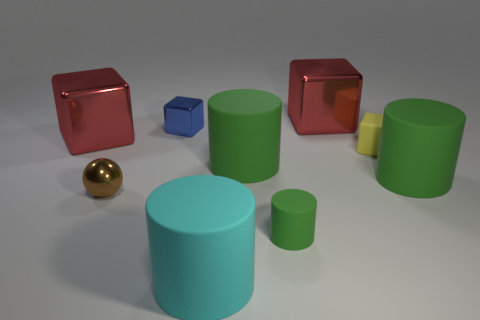Is the material of the large red thing that is on the left side of the blue metallic cube the same as the small cube that is to the right of the blue metal cube?
Your response must be concise. No. Does the small brown sphere have the same material as the small yellow block?
Provide a short and direct response. No. What number of big things are the same material as the small yellow cube?
Your answer should be compact. 3. There is a big matte thing on the right side of the yellow matte object; is its color the same as the tiny matte cylinder?
Give a very brief answer. Yes. How many other small objects have the same shape as the cyan matte thing?
Give a very brief answer. 1. Are there the same number of green matte cylinders left of the small green matte object and small metal balls?
Provide a short and direct response. Yes. The other matte block that is the same size as the blue cube is what color?
Give a very brief answer. Yellow. Is there a large green rubber thing that has the same shape as the brown shiny object?
Give a very brief answer. No. The large red cube on the left side of the red metal block to the right of the big red metal block that is on the left side of the tiny metal sphere is made of what material?
Your answer should be very brief. Metal. How many other things are there of the same size as the cyan thing?
Your response must be concise. 4. 